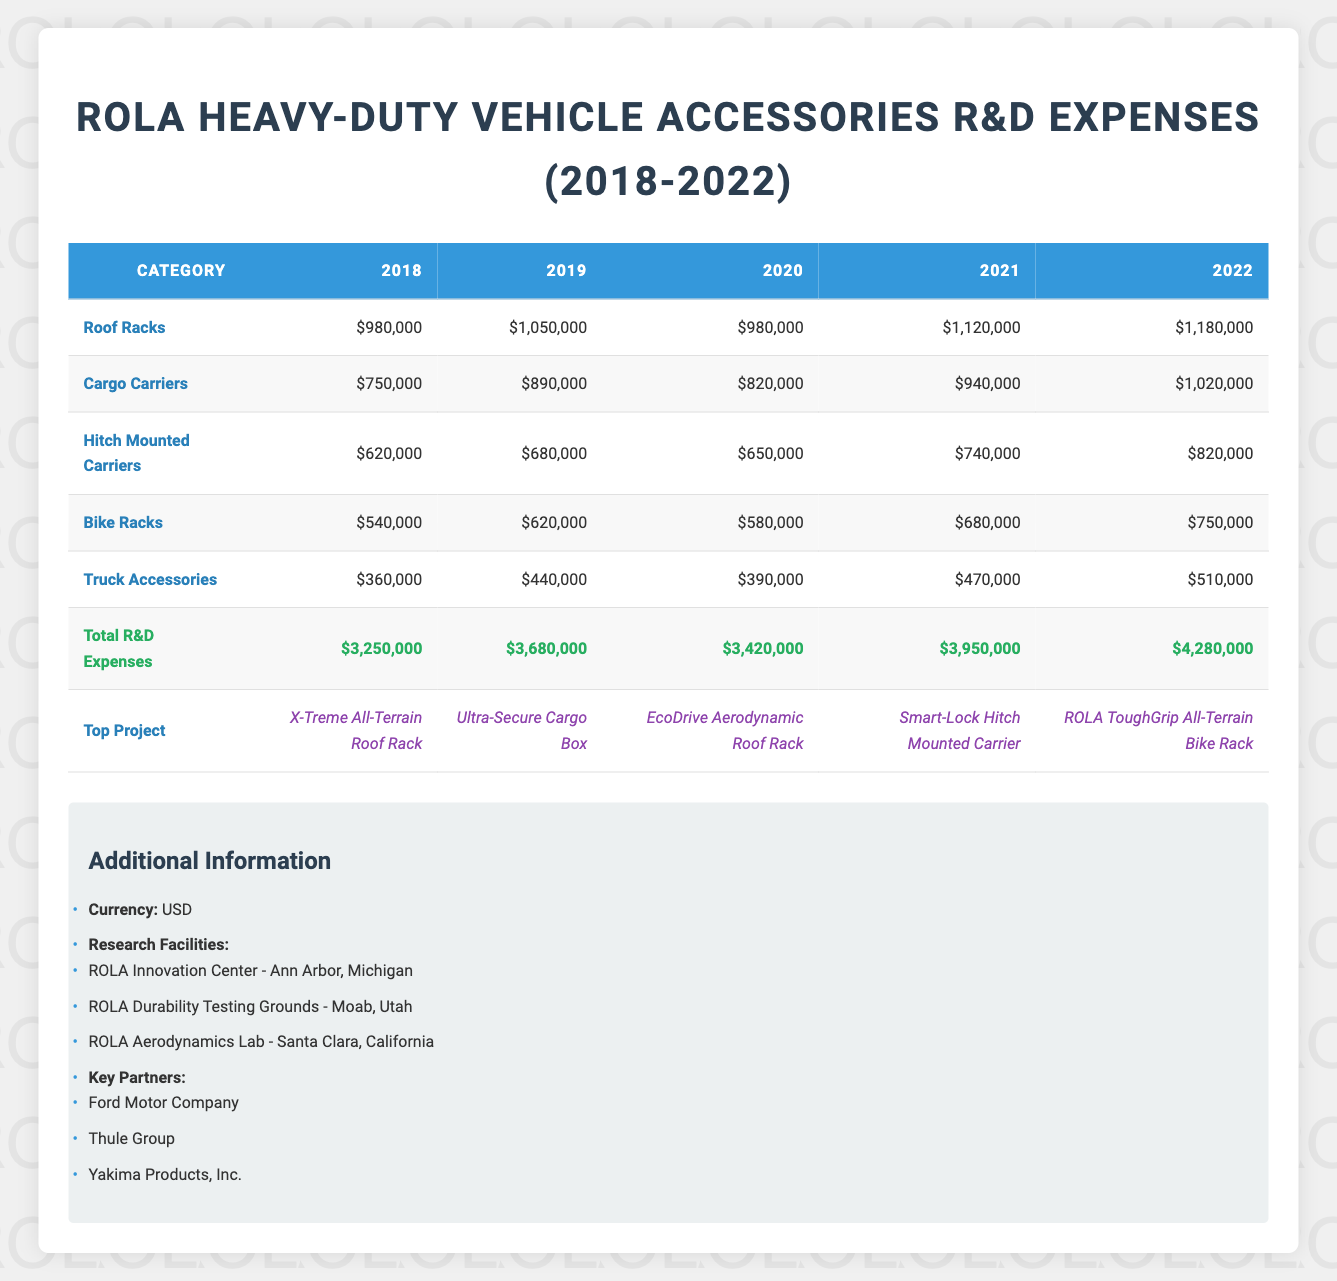What were the total R&D expenses for ROLA in 2021? Referring to the table, the total R&D expenses for the year 2021 is listed as $3,950,000.
Answer: $3,950,000 Which product category had the highest R&D expenses in 2022? Looking at the column for 2022, the product categories are: Roof Racks ($1,180,000), Cargo Carriers ($1,020,000), Hitch Mounted Carriers ($820,000), Bike Racks ($750,000), and Truck Accessories ($510,000). The highest expense is in Roof Racks.
Answer: Roof Racks What is the total increase in R&D expenses from 2018 to 2022? The total expense in 2018 is $3,250,000, and in 2022 it is $4,280,000. To find the increase, we subtract the two values: $4,280,000 - $3,250,000 = $1,030,000.
Answer: $1,030,000 Is the top project in 2019 the same as in 2022? The top project in 2019 is "Ultra-Secure Cargo Box," whereas in 2022 it is "ROLA ToughGrip All-Terrain Bike Rack." Since these projects are different, the answer is no.
Answer: No What was the average R&D expense for all product categories in 2020? First, we sum the expenses for all categories in 2020: Roof Racks ($980,000) + Cargo Carriers ($820,000) + Hitch Mounted Carriers ($650,000) + Bike Racks ($580,000) + Truck Accessories ($390,000) = $3,420,000. As there are five categories, we divide by 5: $3,420,000 / 5 = $684,000.
Answer: $684,000 In which year did ROLA spend the least on Hitch Mounted Carriers? The expenses for Hitch Mounted Carriers by year are: 2018 ($620,000), 2019 ($680,000), 2020 ($650,000), 2021 ($740,000), and 2022 ($820,000). The lowest expense is in 2018, at $620,000.
Answer: 2018 What was the percentage increase in total R&D expenses from 2020 to 2021? The total R&D expenses in 2020 and 2021 are $3,420,000 and $3,950,000, respectively. The increase is $3,950,000 - $3,420,000 = $530,000. To find the percentage increase, we use the formula: (increase / original) * 100. This gives us ($530,000 / $3,420,000) * 100, which equals approximately 15.5%.
Answer: 15.5% Was there a year where ROLA's total R&D expenses declined compared to the previous one? The total expenses in the years are: 2018 ($3,250,000), 2019 ($3,680,000), 2020 ($3,420,000), 2021 ($3,950,000), and 2022 ($4,280,000). Comparing them, there's a decline from 2019 to 2020 since $3,420,000 is less than $3,680,000.
Answer: Yes 